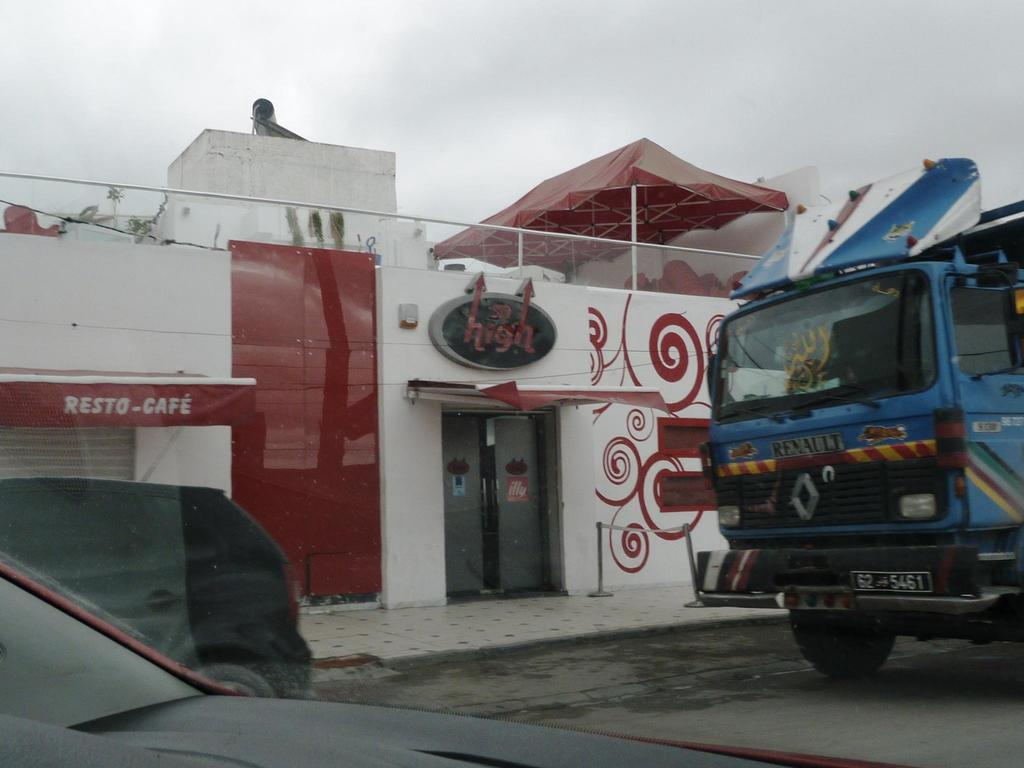What can be seen in the foreground of the image? There are vehicles on the road and a glass in the foreground of the image. What is located in the middle of the image? There is a building in the middle of the image. What is visible at the top of the image? The sky is visible at the top of the image. What verse is being recited by the body in the image? There is no body or verse present in the image. How does the glass join the vehicles on the road in the image? The glass does not join the vehicles on the road in the image; it is a separate object in the foreground. 